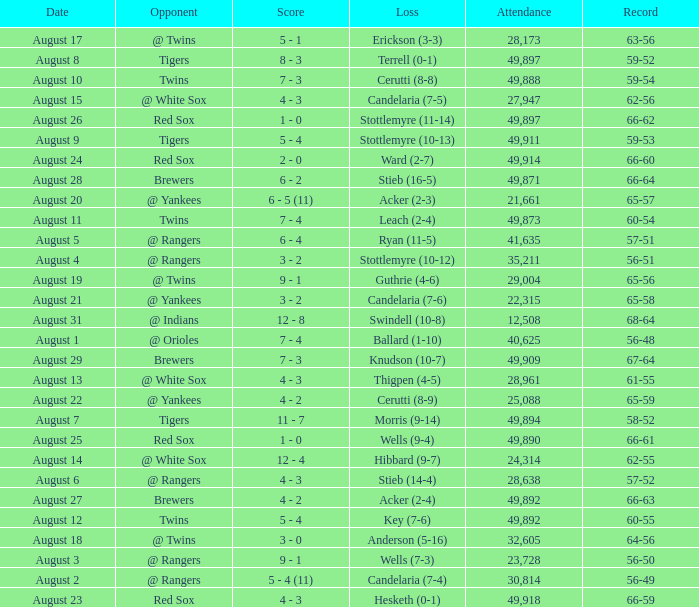What was the record of the game that had a loss of Stottlemyre (10-12)? 56-51. 